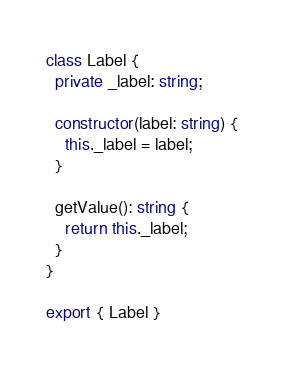<code> <loc_0><loc_0><loc_500><loc_500><_TypeScript_>class Label {
  private _label: string;

  constructor(label: string) {
    this._label = label;
  }

  getValue(): string {
    return this._label;
  }
}

export { Label }
</code> 